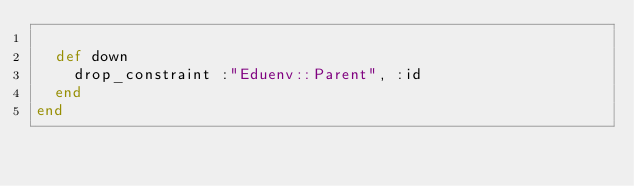Convert code to text. <code><loc_0><loc_0><loc_500><loc_500><_Ruby_>
  def down
    drop_constraint :"Eduenv::Parent", :id
  end
end
</code> 